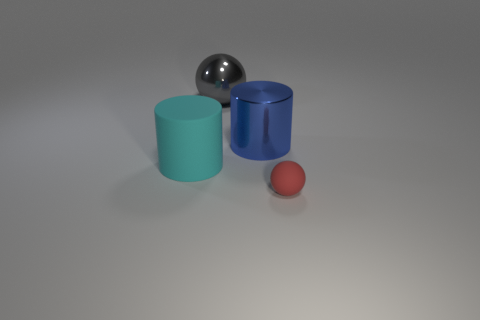Add 2 large cyan shiny blocks. How many objects exist? 6 Add 3 cyan matte things. How many cyan matte things are left? 4 Add 3 cyan objects. How many cyan objects exist? 4 Subtract 1 gray balls. How many objects are left? 3 Subtract all large cyan shiny balls. Subtract all large gray objects. How many objects are left? 3 